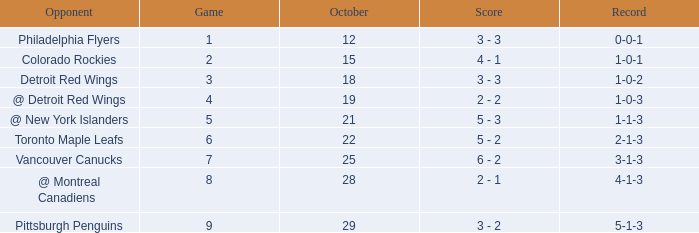Name the least game for record of 1-0-2 3.0. 